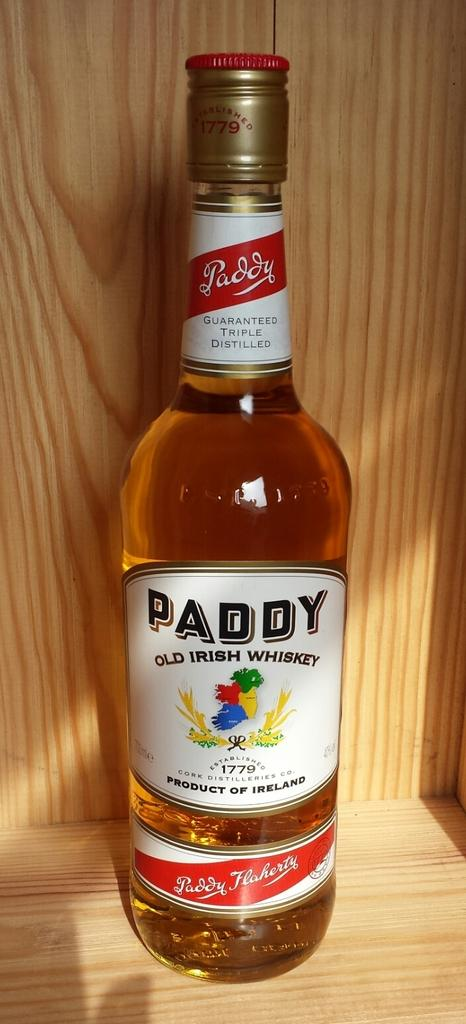Provide a one-sentence caption for the provided image. A full bottle of Paddy whiskey still has the gold seal intact. 